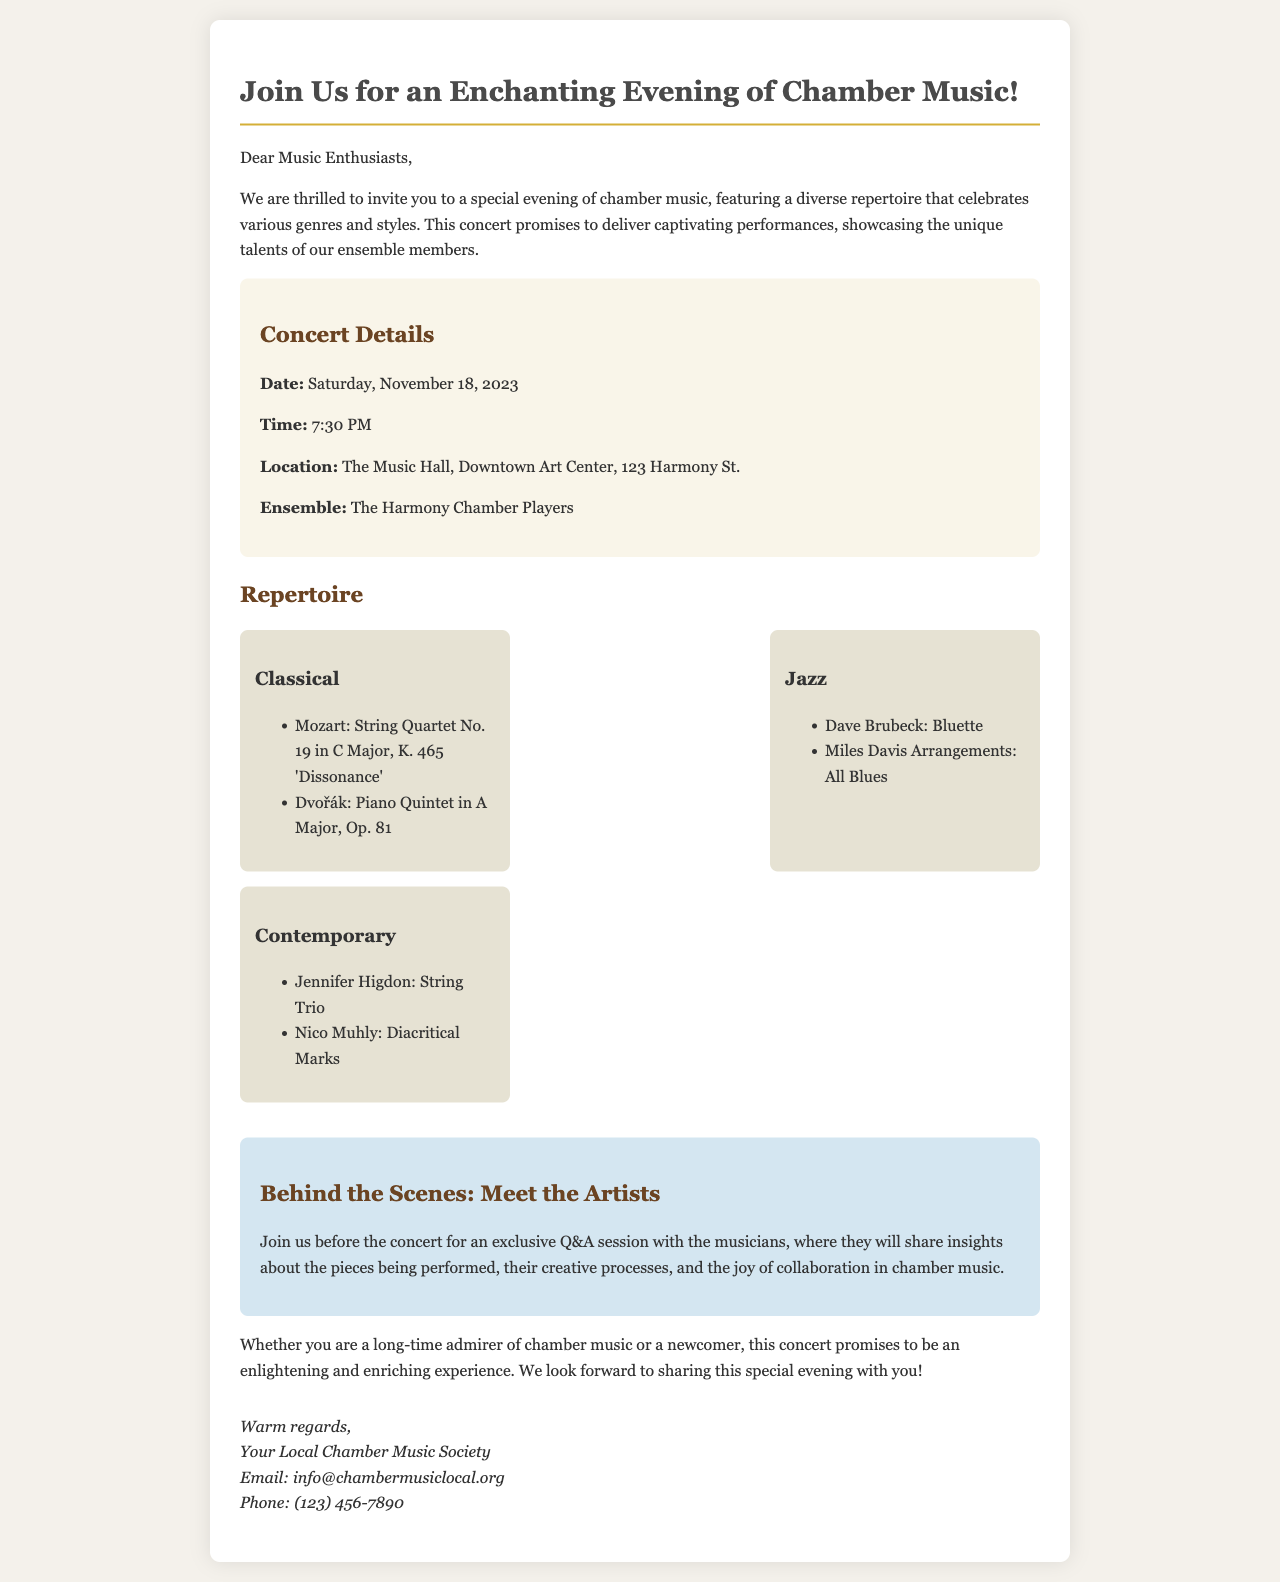what is the concert date? The concert date is clearly stated in the document, which is Saturday, November 18, 2023.
Answer: Saturday, November 18, 2023 what time does the concert start? The start time of the concert is mentioned in the details, which is 7:30 PM.
Answer: 7:30 PM where is the concert taking place? The location of the concert is provided, which is The Music Hall, Downtown Art Center, 123 Harmony St.
Answer: The Music Hall, Downtown Art Center, 123 Harmony St who is performing at the concert? The ensemble performing at the concert is explicitly named in the document as The Harmony Chamber Players.
Answer: The Harmony Chamber Players which piece is by Dvořák? The repertoire section includes a piece listed under Classical, which is the Piano Quintet in A Major, Op. 81 by Dvořák.
Answer: Piano Quintet in A Major, Op. 81 what genre is "Bluette"? The piece "Bluette" is mentioned under the Jazz section of the repertoire.
Answer: Jazz when can attendees meet the artists? Attendees can meet the artists before the concert, as indicated in the behind-the-scenes section.
Answer: Before the concert what type of session will be held with the musicians? The document describes the session with the musicians as a Q&A session.
Answer: Q&A session who organized the concert? The organizing entity is mentioned at the end of the document as Your Local Chamber Music Society.
Answer: Your Local Chamber Music Society 